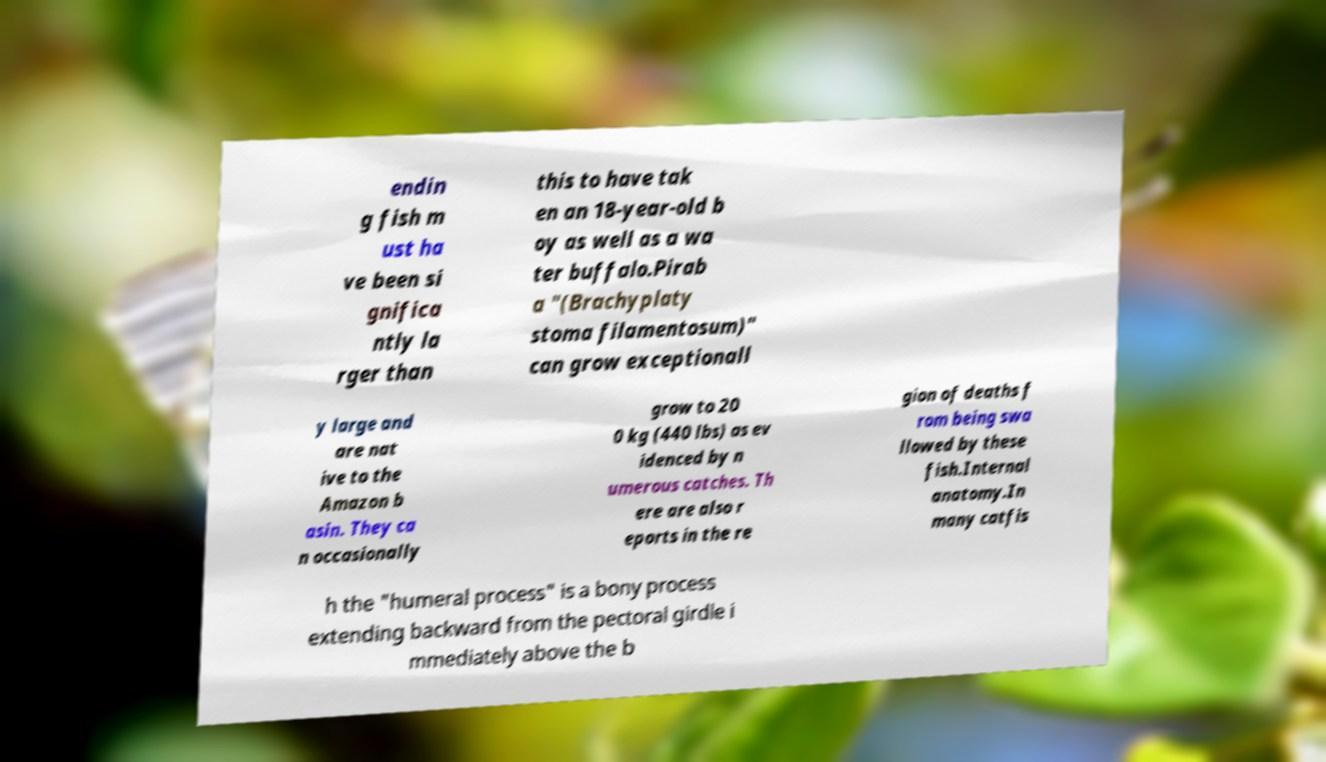Please read and relay the text visible in this image. What does it say? endin g fish m ust ha ve been si gnifica ntly la rger than this to have tak en an 18-year-old b oy as well as a wa ter buffalo.Pirab a "(Brachyplaty stoma filamentosum)" can grow exceptionall y large and are nat ive to the Amazon b asin. They ca n occasionally grow to 20 0 kg (440 lbs) as ev idenced by n umerous catches. Th ere are also r eports in the re gion of deaths f rom being swa llowed by these fish.Internal anatomy.In many catfis h the "humeral process" is a bony process extending backward from the pectoral girdle i mmediately above the b 